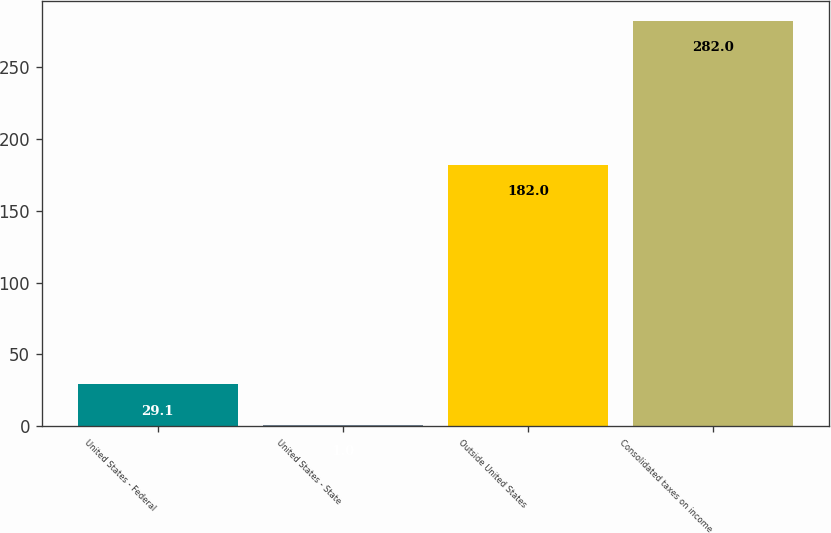<chart> <loc_0><loc_0><loc_500><loc_500><bar_chart><fcel>United States - Federal<fcel>United States - State<fcel>Outside United States<fcel>Consolidated taxes on income<nl><fcel>29.1<fcel>1<fcel>182<fcel>282<nl></chart> 